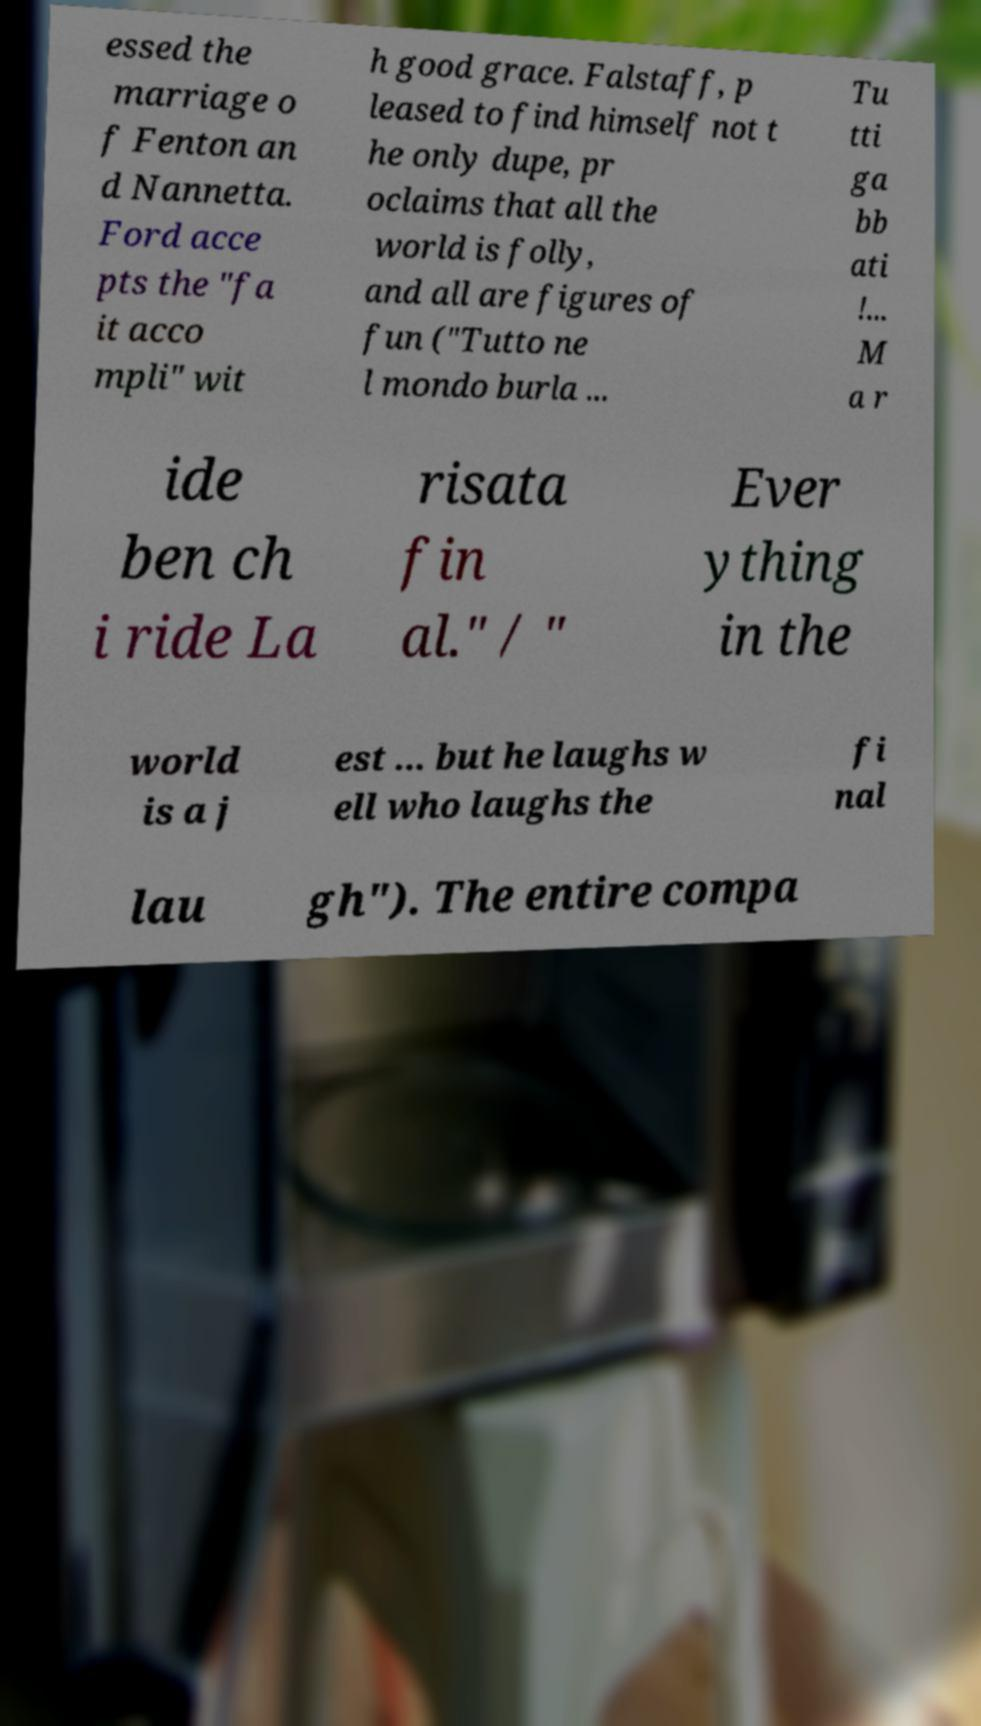Please read and relay the text visible in this image. What does it say? essed the marriage o f Fenton an d Nannetta. Ford acce pts the "fa it acco mpli" wit h good grace. Falstaff, p leased to find himself not t he only dupe, pr oclaims that all the world is folly, and all are figures of fun ("Tutto ne l mondo burla ... Tu tti ga bb ati !... M a r ide ben ch i ride La risata fin al." / " Ever ything in the world is a j est ... but he laughs w ell who laughs the fi nal lau gh"). The entire compa 